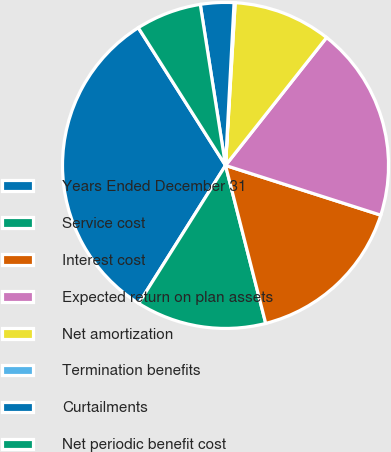<chart> <loc_0><loc_0><loc_500><loc_500><pie_chart><fcel>Years Ended December 31<fcel>Service cost<fcel>Interest cost<fcel>Expected return on plan assets<fcel>Net amortization<fcel>Termination benefits<fcel>Curtailments<fcel>Net periodic benefit cost<nl><fcel>32.08%<fcel>12.9%<fcel>16.1%<fcel>19.29%<fcel>9.7%<fcel>0.11%<fcel>3.31%<fcel>6.51%<nl></chart> 